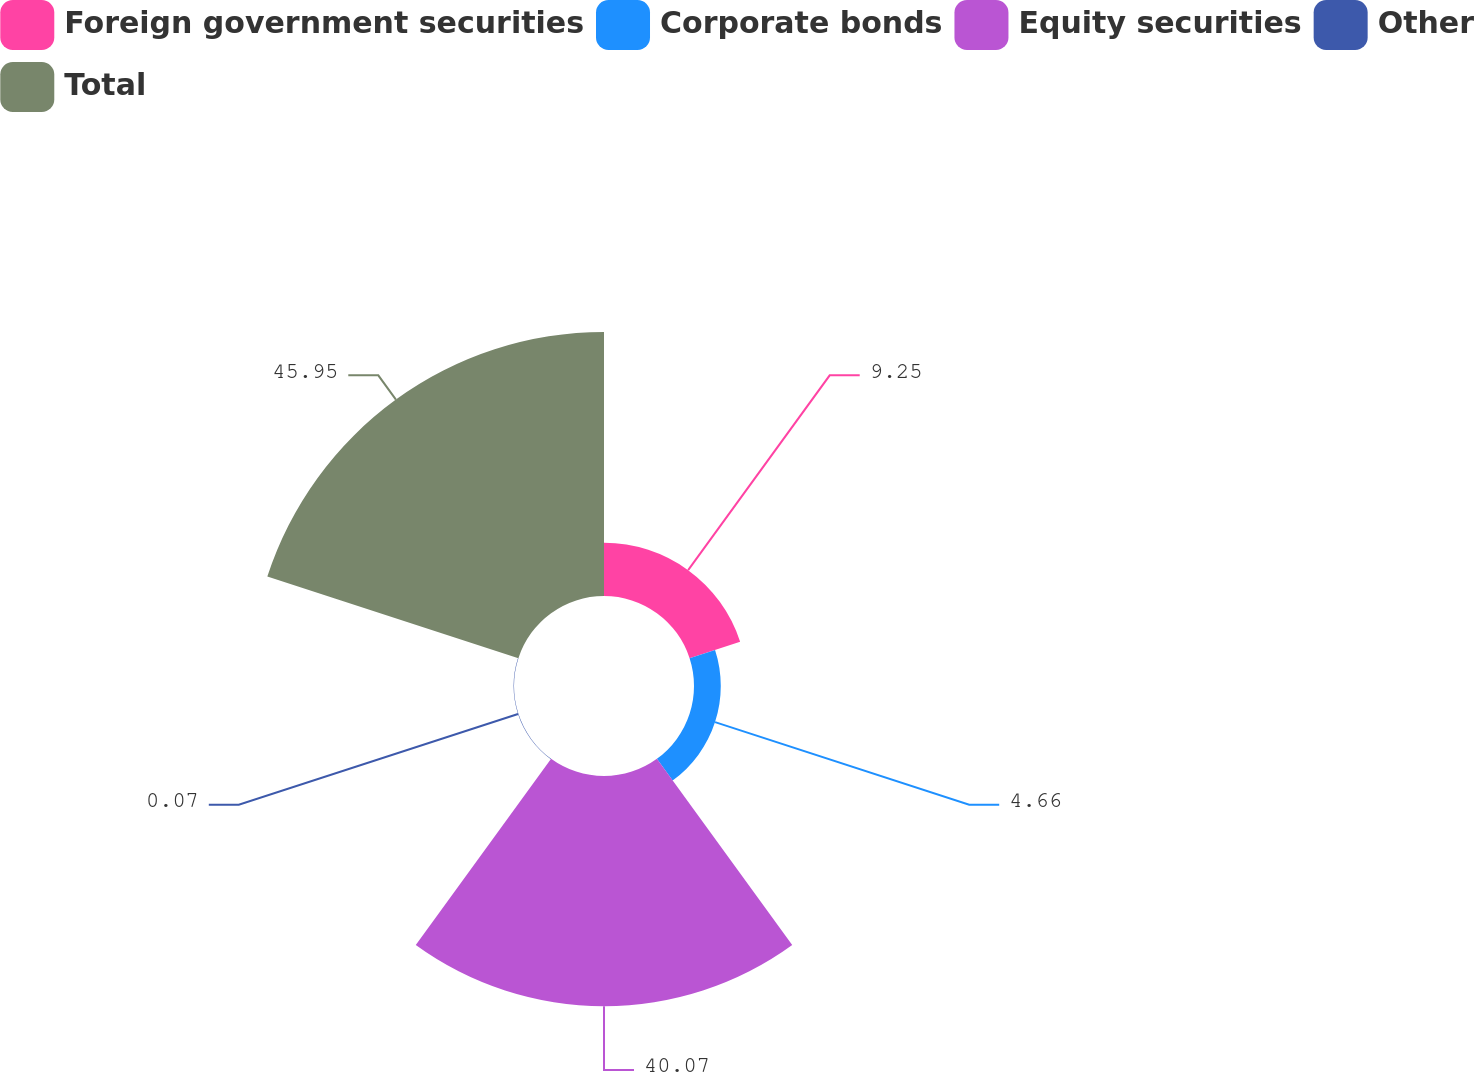<chart> <loc_0><loc_0><loc_500><loc_500><pie_chart><fcel>Foreign government securities<fcel>Corporate bonds<fcel>Equity securities<fcel>Other<fcel>Total<nl><fcel>9.25%<fcel>4.66%<fcel>40.07%<fcel>0.07%<fcel>45.95%<nl></chart> 